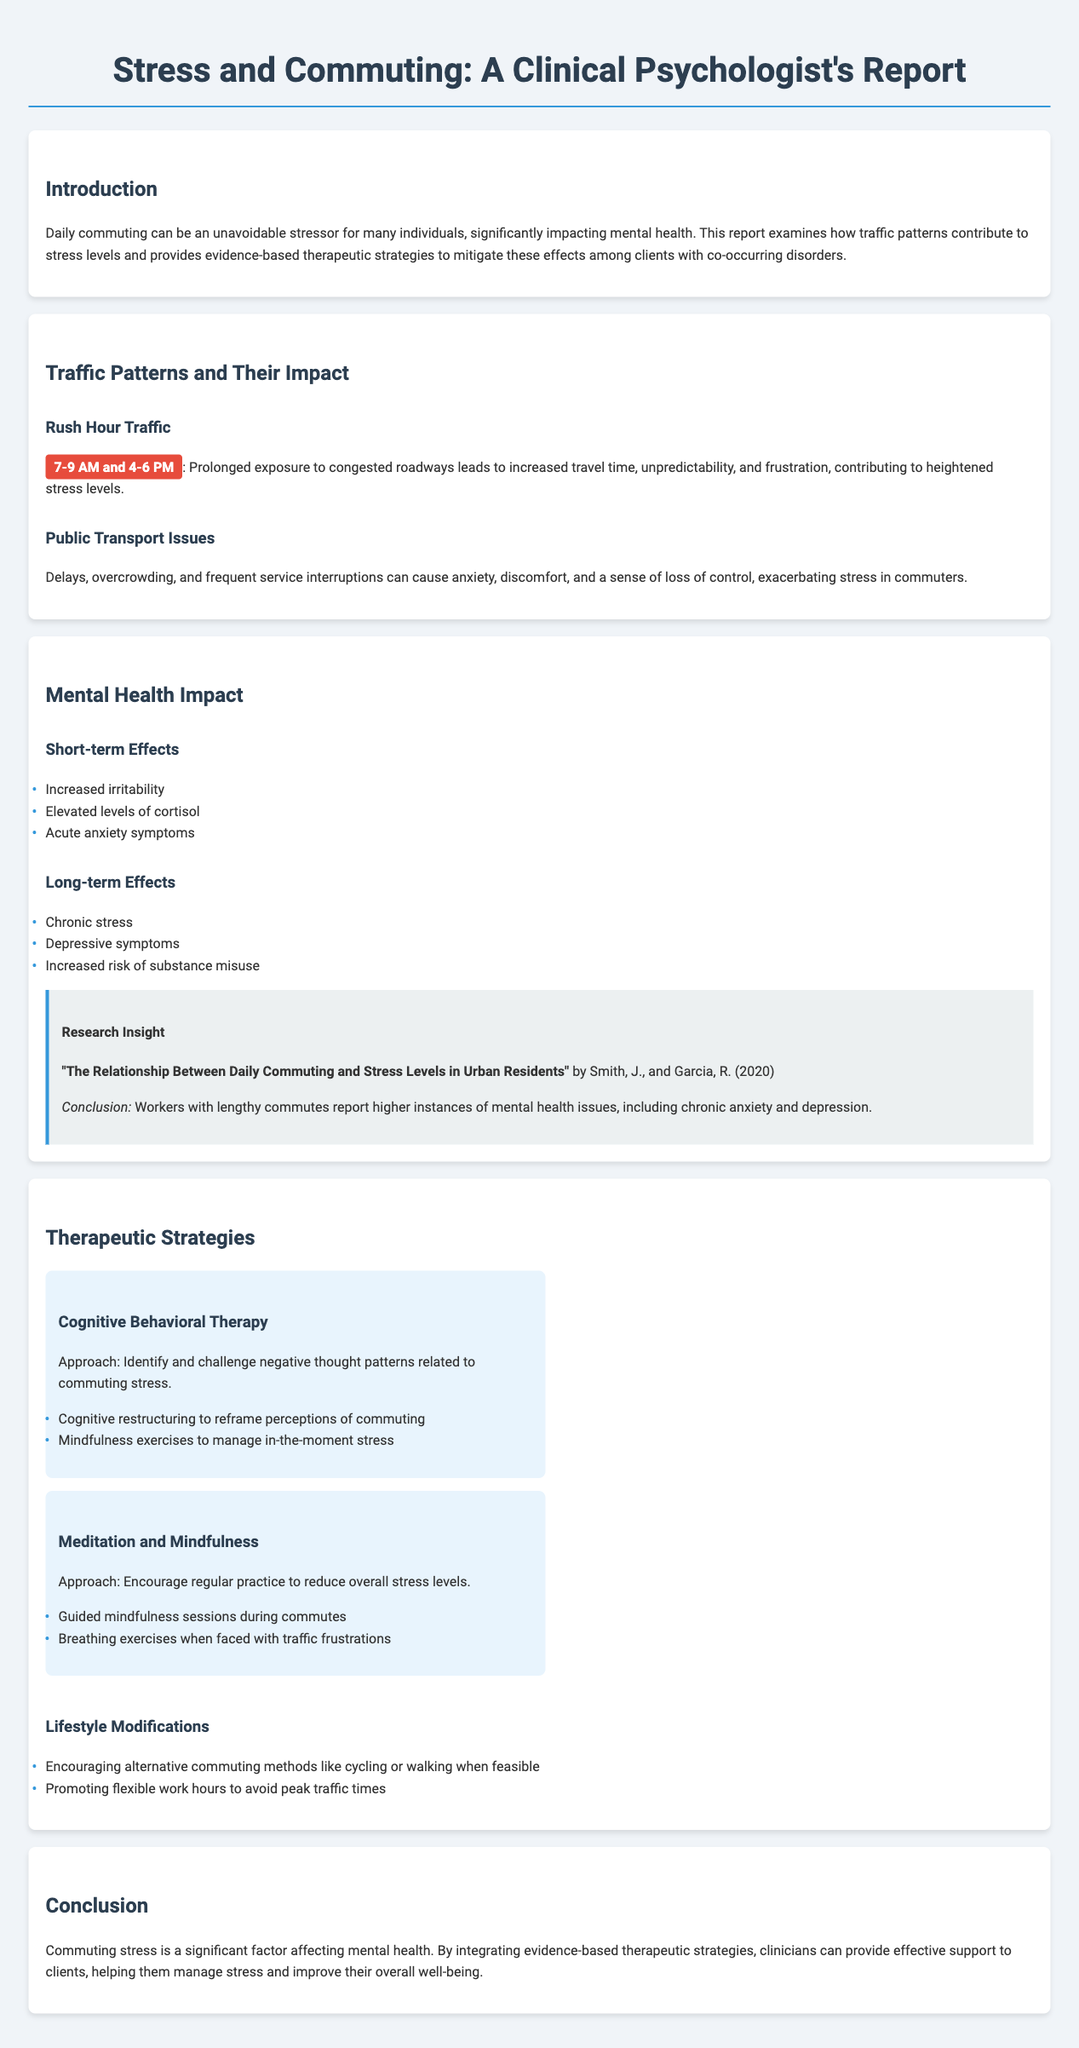what are the peak traffic hours mentioned in the report? The report highlights specific times when traffic congestion is typically highest, noted as the periods when commuting is most challenging.
Answer: 7-9 AM and 4-6 PM what is a short-term mental health effect of commuting stress? The report lists several short-term effects on mental health that can arise from commuting stress, indicating immediate reactions.
Answer: Increased irritability what is a long-term effect of commuting on mental health? Several long-term consequences of commuting stress are discussed, detailing ongoing impacts on mental well-being.
Answer: Chronic stress which therapy focuses on negative thought patterns related to commuting stress? The document outlines specific therapeutic approaches and strategies, identifying one that targets cognitive aspects of commuting challenges.
Answer: Cognitive Behavioral Therapy what lifestyle modification is proposed in the report? The report suggests various adjustments to commuting habits and routines that may alleviate stress, including practical alternatives.
Answer: Encouraging alternative commuting methods like cycling or walking which research insight is cited in the document? The report references a particular study that illustrates the correlation between commuting and stress, summarizing its key findings.
Answer: "The Relationship Between Daily Commuting and Stress Levels in Urban Residents" what is one method under Meditation and Mindfulness therapy? The report provides examples of therapeutic practices under meditation and mindfulness that can help alleviate commuting stress.
Answer: Guided mindfulness sessions during commutes what are the overall therapeutic strategies emphasized in the report? It discusses various approaches to address commuting-related stress and improve mental health, indicating a comprehensive method for mitigating effects.
Answer: Evidence-based therapeutic strategies 